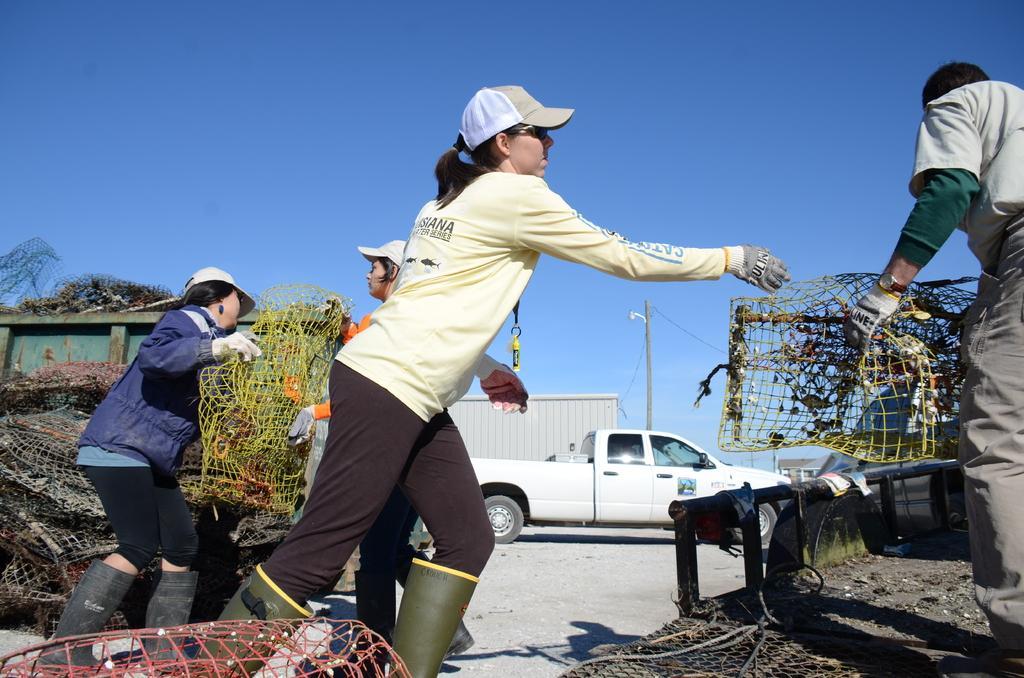How would you summarize this image in a sentence or two? In this image we can see few vehicles and people, among them some are holding the objects, we can see some objects on the ground, in the background we can see a pole and the sky. 